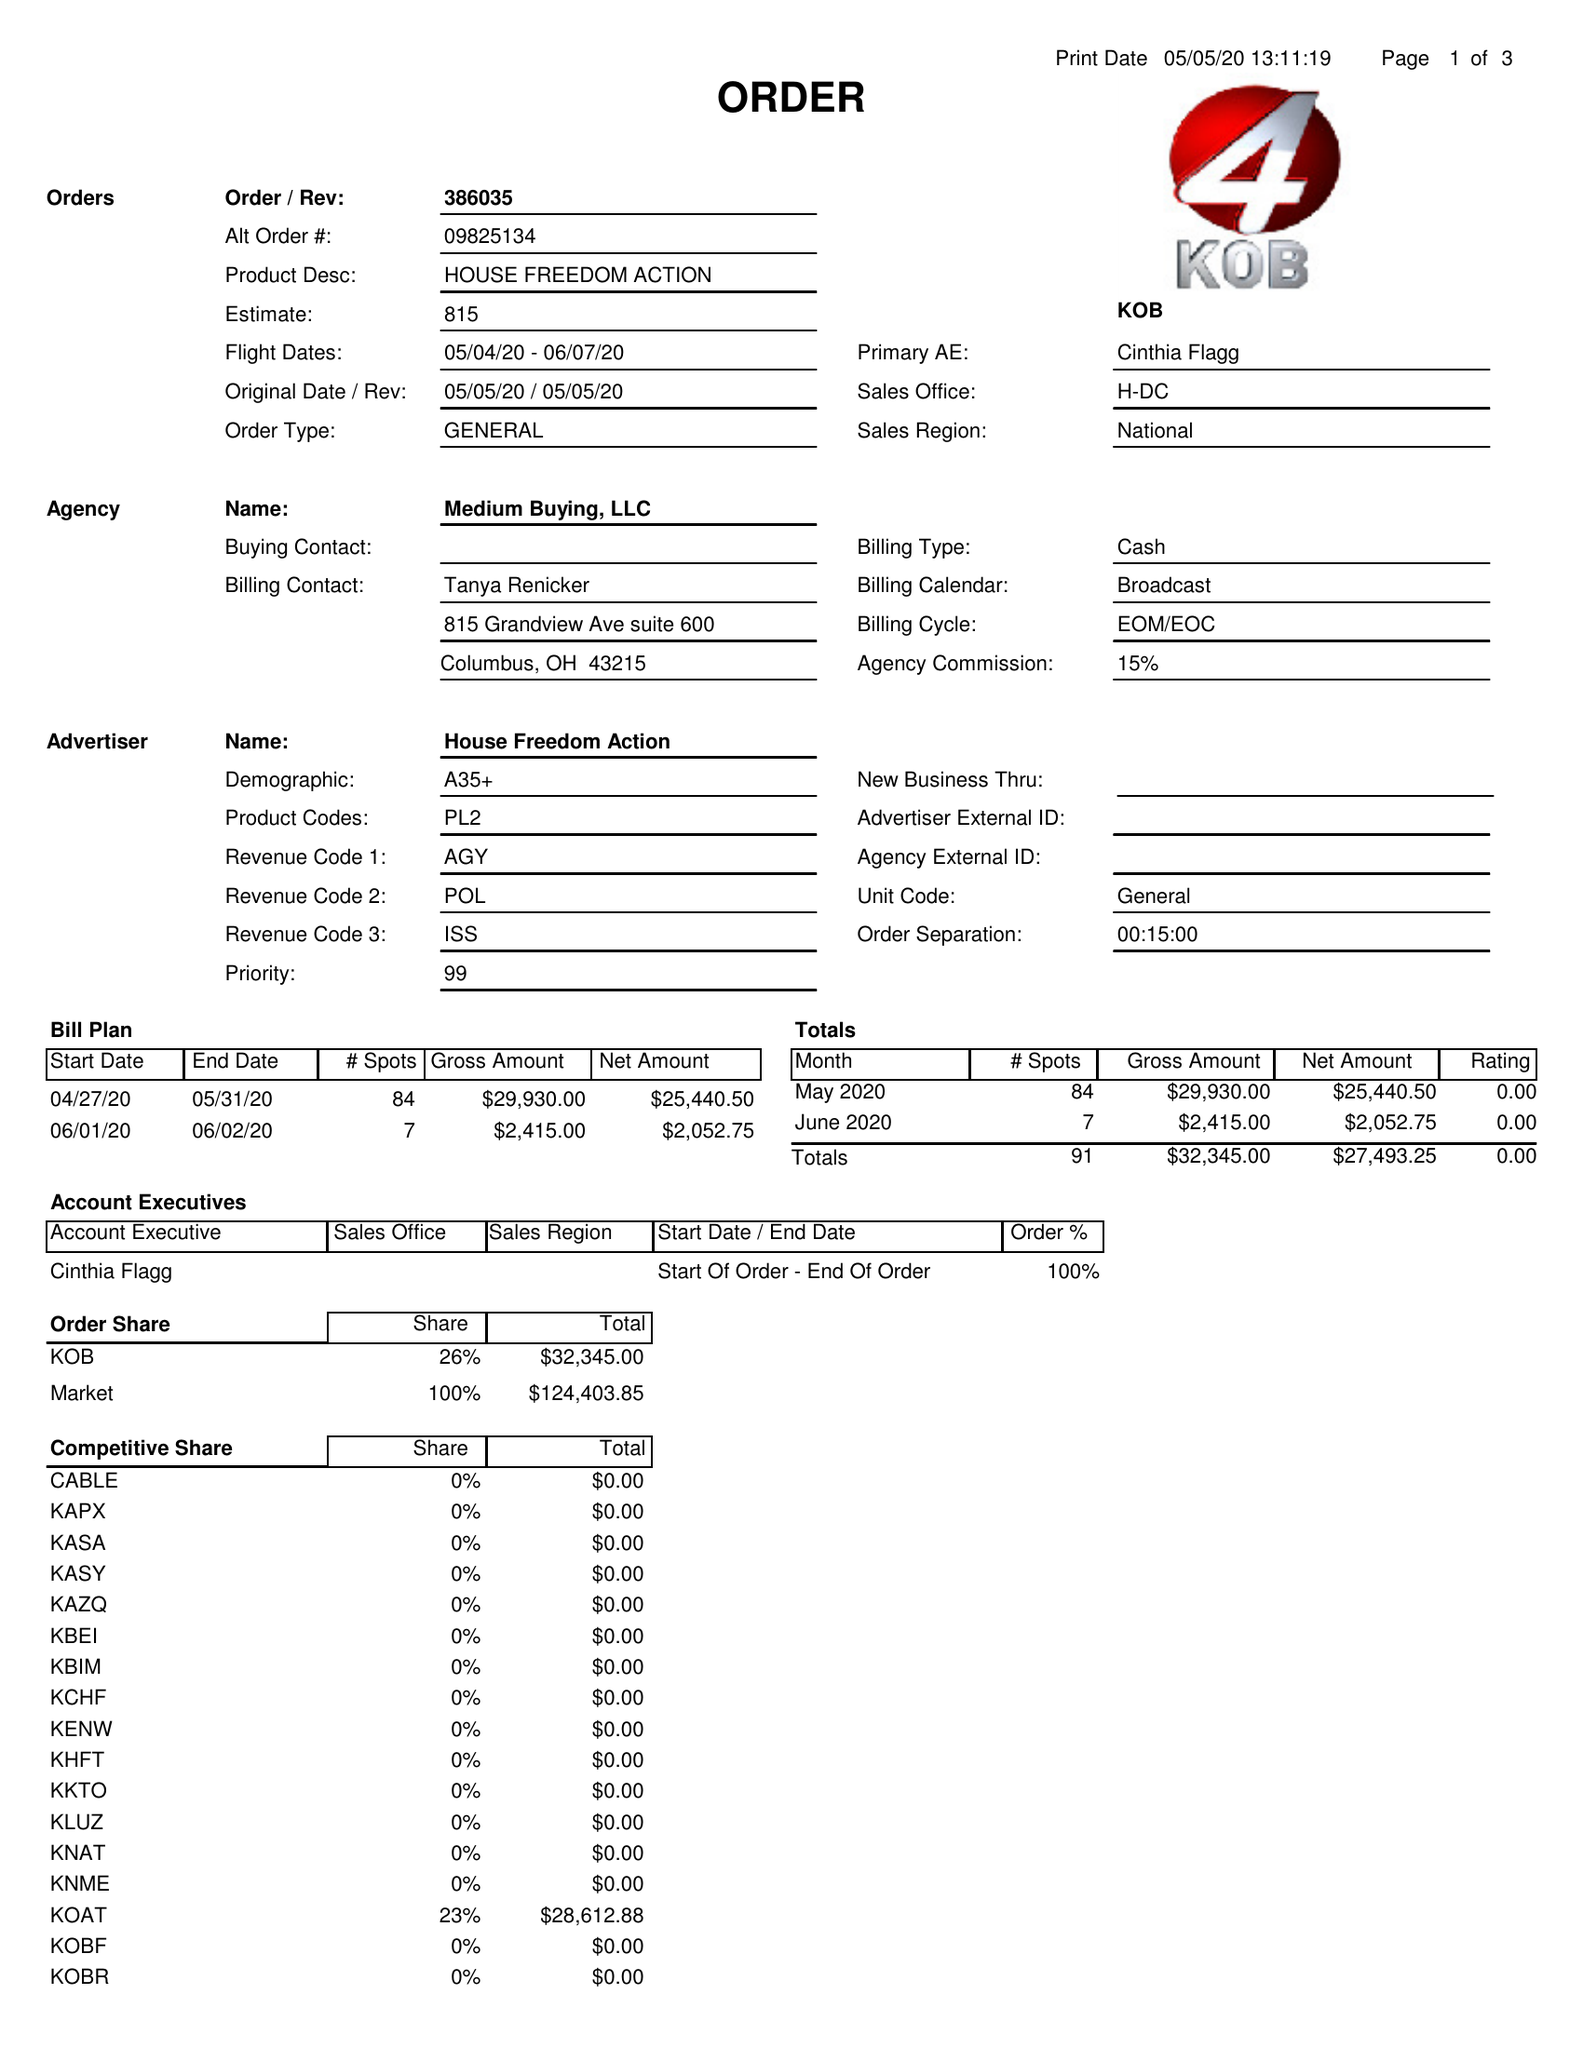What is the value for the flight_from?
Answer the question using a single word or phrase. 05/04/20 